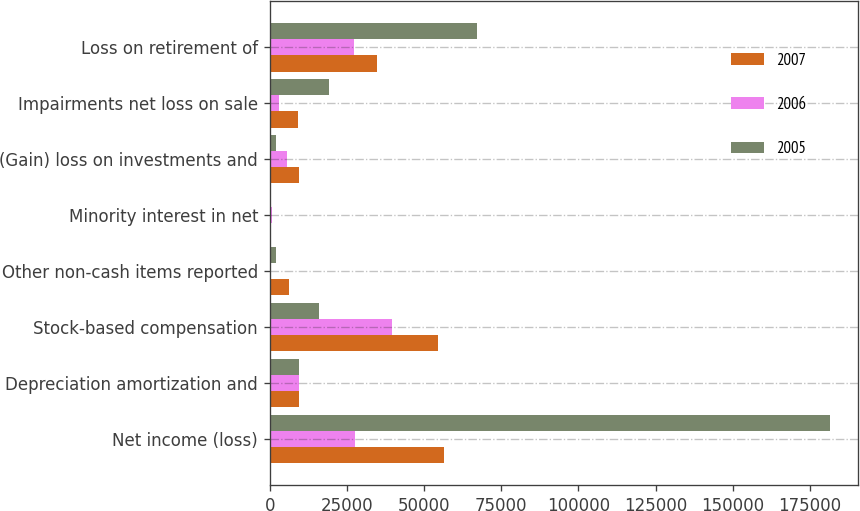<chart> <loc_0><loc_0><loc_500><loc_500><stacked_bar_chart><ecel><fcel>Net income (loss)<fcel>Depreciation amortization and<fcel>Stock-based compensation<fcel>Other non-cash items reported<fcel>Minority interest in net<fcel>(Gain) loss on investments and<fcel>Impairments net loss on sale<fcel>Loss on retirement of<nl><fcel>2007<fcel>56316<fcel>9470<fcel>54603<fcel>6192<fcel>338<fcel>9470<fcel>9214<fcel>34826<nl><fcel>2006<fcel>27484<fcel>9470<fcel>39502<fcel>444<fcel>784<fcel>5453<fcel>2958<fcel>27223<nl><fcel>2005<fcel>181359<fcel>9470<fcel>15930<fcel>2145<fcel>575<fcel>2078<fcel>19096<fcel>67110<nl></chart> 